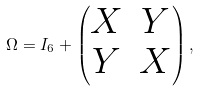Convert formula to latex. <formula><loc_0><loc_0><loc_500><loc_500>\Omega = I _ { 6 } + \begin{pmatrix} X & Y \\ Y & X \end{pmatrix} ,</formula> 